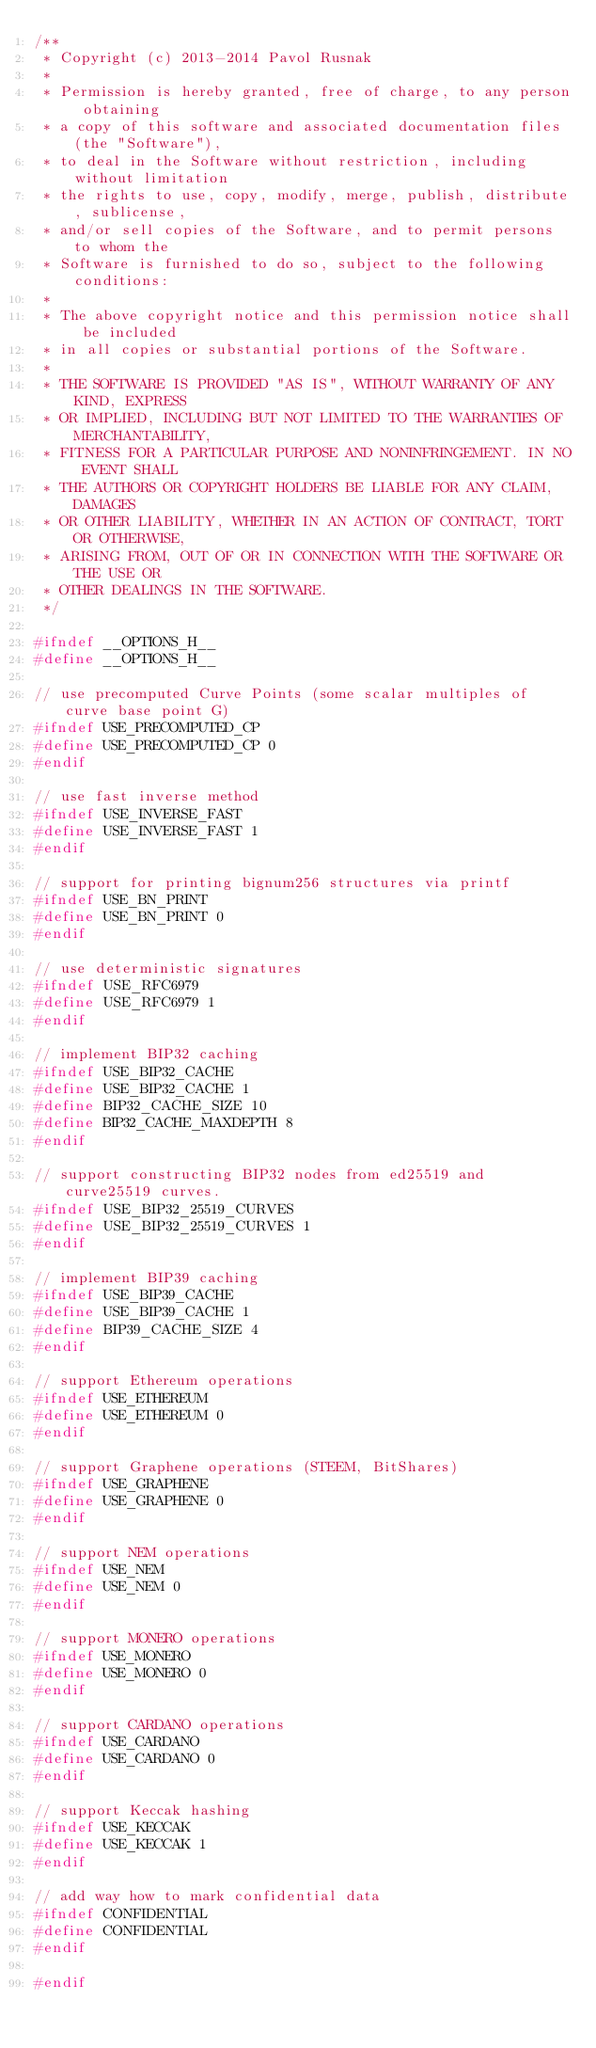<code> <loc_0><loc_0><loc_500><loc_500><_C_>/**
 * Copyright (c) 2013-2014 Pavol Rusnak
 *
 * Permission is hereby granted, free of charge, to any person obtaining
 * a copy of this software and associated documentation files (the "Software"),
 * to deal in the Software without restriction, including without limitation
 * the rights to use, copy, modify, merge, publish, distribute, sublicense,
 * and/or sell copies of the Software, and to permit persons to whom the
 * Software is furnished to do so, subject to the following conditions:
 *
 * The above copyright notice and this permission notice shall be included
 * in all copies or substantial portions of the Software.
 *
 * THE SOFTWARE IS PROVIDED "AS IS", WITHOUT WARRANTY OF ANY KIND, EXPRESS
 * OR IMPLIED, INCLUDING BUT NOT LIMITED TO THE WARRANTIES OF MERCHANTABILITY,
 * FITNESS FOR A PARTICULAR PURPOSE AND NONINFRINGEMENT. IN NO EVENT SHALL
 * THE AUTHORS OR COPYRIGHT HOLDERS BE LIABLE FOR ANY CLAIM, DAMAGES
 * OR OTHER LIABILITY, WHETHER IN AN ACTION OF CONTRACT, TORT OR OTHERWISE,
 * ARISING FROM, OUT OF OR IN CONNECTION WITH THE SOFTWARE OR THE USE OR
 * OTHER DEALINGS IN THE SOFTWARE.
 */

#ifndef __OPTIONS_H__
#define __OPTIONS_H__

// use precomputed Curve Points (some scalar multiples of curve base point G)
#ifndef USE_PRECOMPUTED_CP
#define USE_PRECOMPUTED_CP 0
#endif

// use fast inverse method
#ifndef USE_INVERSE_FAST
#define USE_INVERSE_FAST 1
#endif

// support for printing bignum256 structures via printf
#ifndef USE_BN_PRINT
#define USE_BN_PRINT 0
#endif

// use deterministic signatures
#ifndef USE_RFC6979
#define USE_RFC6979 1
#endif

// implement BIP32 caching
#ifndef USE_BIP32_CACHE
#define USE_BIP32_CACHE 1
#define BIP32_CACHE_SIZE 10
#define BIP32_CACHE_MAXDEPTH 8
#endif

// support constructing BIP32 nodes from ed25519 and curve25519 curves.
#ifndef USE_BIP32_25519_CURVES
#define USE_BIP32_25519_CURVES 1
#endif

// implement BIP39 caching
#ifndef USE_BIP39_CACHE
#define USE_BIP39_CACHE 1
#define BIP39_CACHE_SIZE 4
#endif

// support Ethereum operations
#ifndef USE_ETHEREUM
#define USE_ETHEREUM 0
#endif

// support Graphene operations (STEEM, BitShares)
#ifndef USE_GRAPHENE
#define USE_GRAPHENE 0
#endif

// support NEM operations
#ifndef USE_NEM
#define USE_NEM 0
#endif

// support MONERO operations
#ifndef USE_MONERO
#define USE_MONERO 0
#endif

// support CARDANO operations
#ifndef USE_CARDANO
#define USE_CARDANO 0
#endif

// support Keccak hashing
#ifndef USE_KECCAK
#define USE_KECCAK 1
#endif

// add way how to mark confidential data
#ifndef CONFIDENTIAL
#define CONFIDENTIAL
#endif

#endif
</code> 